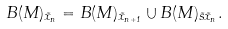Convert formula to latex. <formula><loc_0><loc_0><loc_500><loc_500>B ( M ) _ { \tilde { x } _ { n } } = B ( M ) _ { \tilde { x } _ { n + 1 } } \cup B ( M ) _ { \tilde { s } \tilde { x } _ { n } } .</formula> 